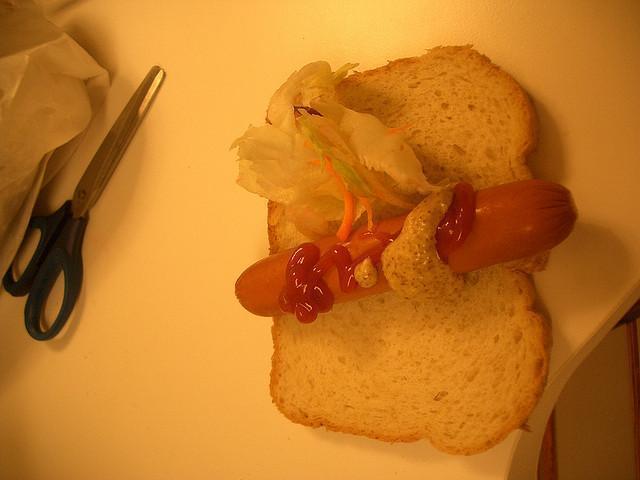How many different vegetables were used to create the red sauce on the hot dog?
Indicate the correct response and explain using: 'Answer: answer
Rationale: rationale.'
Options: One, three, four, two. Answer: one.
Rationale: Tomatoes are the main ingredient for the sauce that we put on our food. 